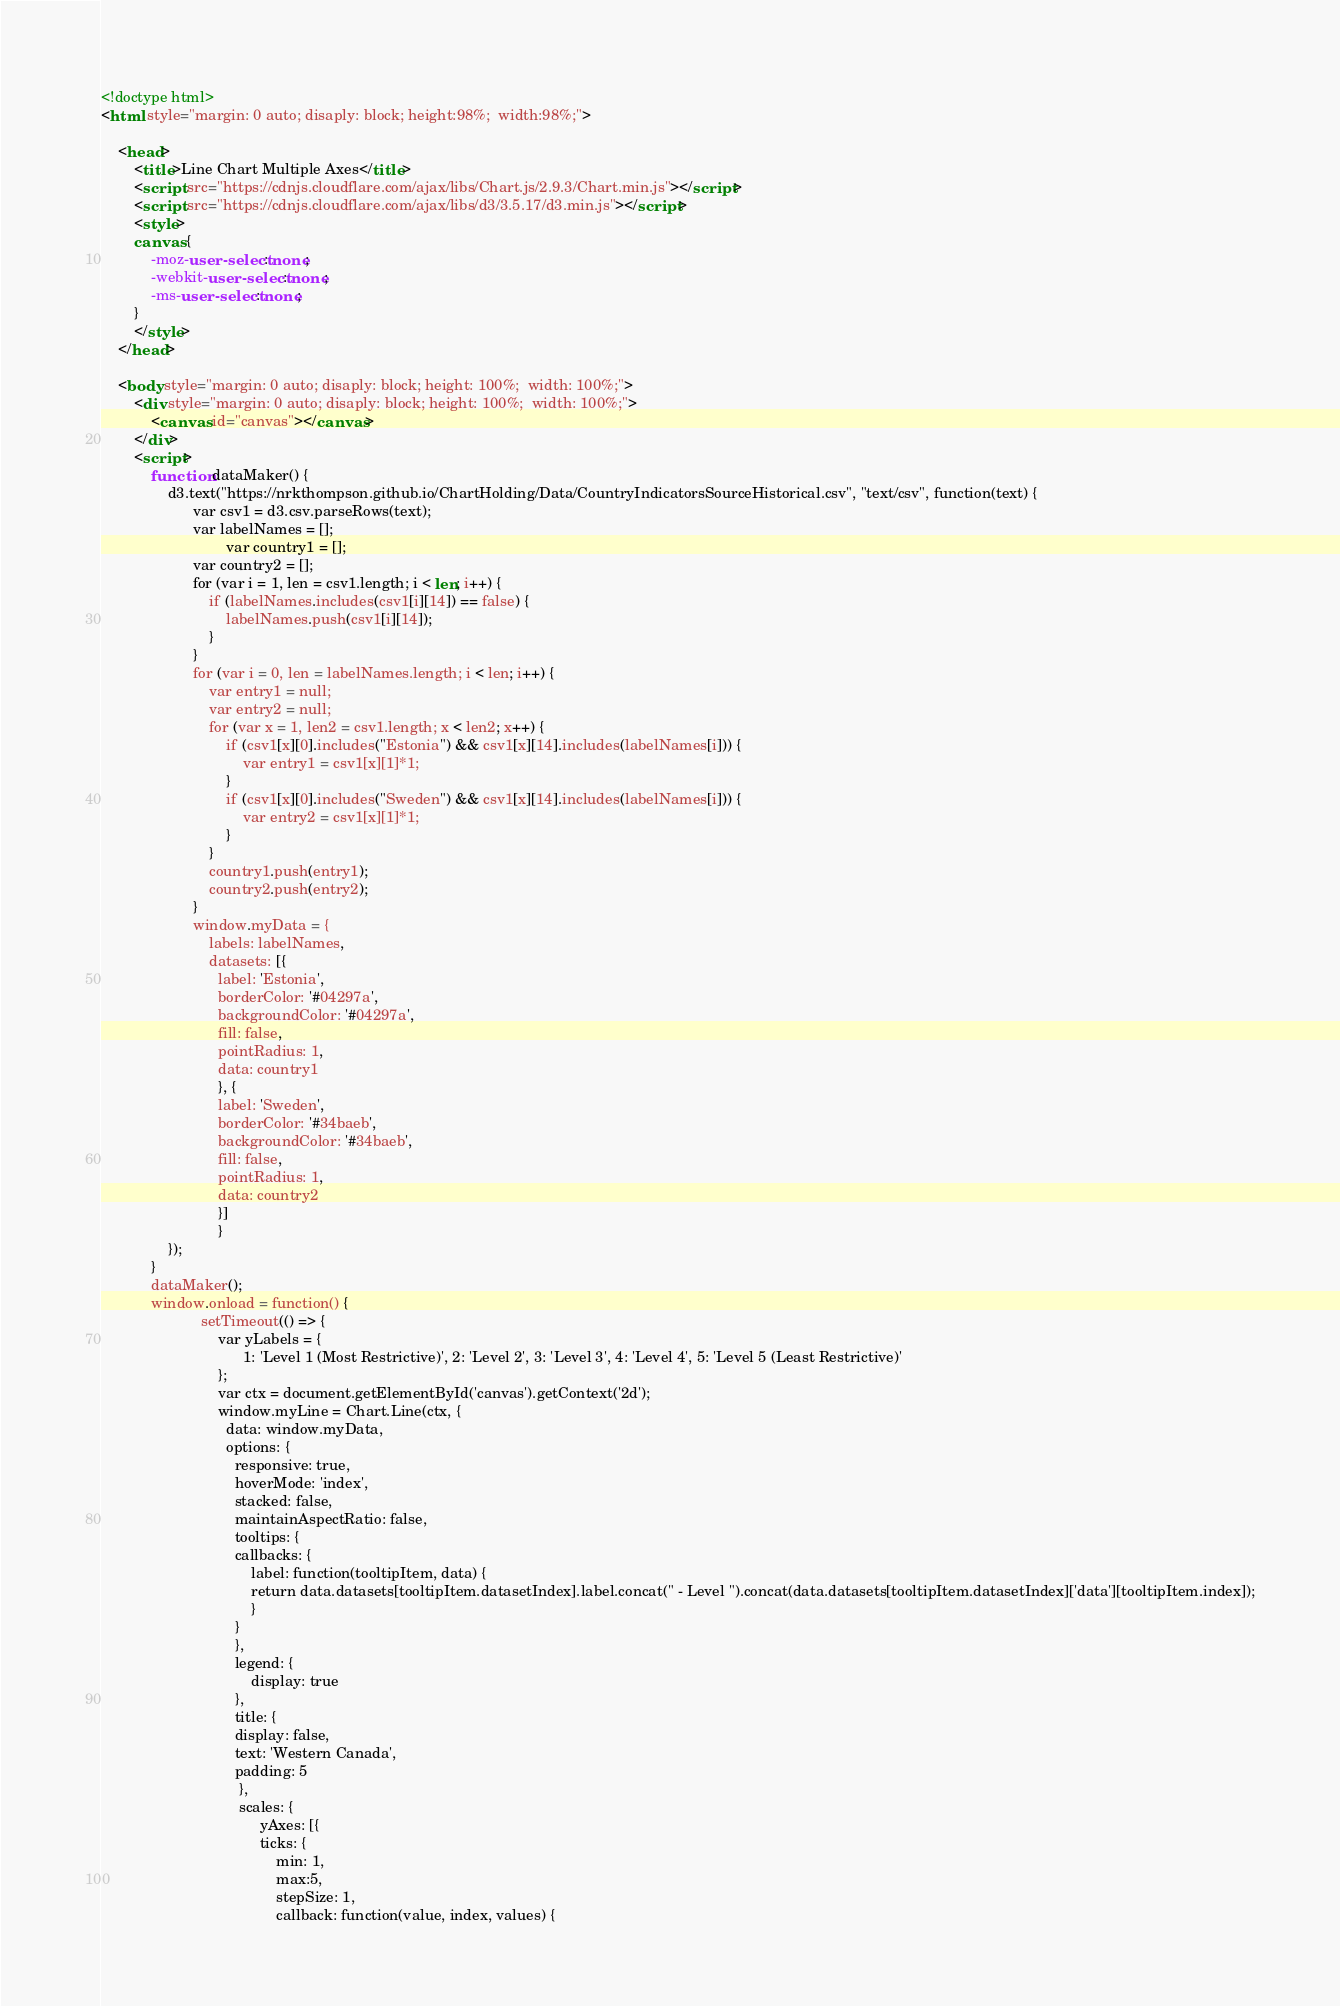Convert code to text. <code><loc_0><loc_0><loc_500><loc_500><_HTML_>
<!doctype html>
<html style="margin: 0 auto; disaply: block; height:98%;  width:98%;">

	<head>
		<title>Line Chart Multiple Axes</title>
		<script src="https://cdnjs.cloudflare.com/ajax/libs/Chart.js/2.9.3/Chart.min.js"></script>
		<script src="https://cdnjs.cloudflare.com/ajax/libs/d3/3.5.17/d3.min.js"></script>
		<style>
		canvas {
			-moz-user-select: none;
			-webkit-user-select: none;
			-ms-user-select: none;
		}
		</style>
	</head>

	<body style="margin: 0 auto; disaply: block; height: 100%;  width: 100%;">
		<div style="margin: 0 auto; disaply: block; height: 100%;  width: 100%;">
			<canvas id="canvas"></canvas>
		</div>
		<script>
			function dataMaker() {
				d3.text("https://nrkthompson.github.io/ChartHolding/Data/CountryIndicatorsSourceHistorical.csv", "text/csv", function(text) {
					  var csv1 = d3.csv.parseRows(text);
					  var labelNames = [];
            				  var country1 = [];
					  var country2 = [];
					  for (var i = 1, len = csv1.length; i < len; i++) {
						  if (labelNames.includes(csv1[i][14]) == false) {
							  labelNames.push(csv1[i][14]);
						  }
					  }
					  for (var i = 0, len = labelNames.length; i < len; i++) {
						  var entry1 = null;
						  var entry2 = null;
						  for (var x = 1, len2 = csv1.length; x < len2; x++) {
							  if (csv1[x][0].includes("Estonia") && csv1[x][14].includes(labelNames[i])) {
								  var entry1 = csv1[x][1]*1;
							  }
							  if (csv1[x][0].includes("Sweden") && csv1[x][14].includes(labelNames[i])) {
								  var entry2 = csv1[x][1]*1;
							  }
						  }
						  country1.push(entry1);
						  country2.push(entry2);
					  }
					  window.myData = {
						  labels: labelNames,
						  datasets: [{
						    label: 'Estonia',
						    borderColor: '#04297a',
						    backgroundColor: '#04297a',
						    fill: false,
						    pointRadius: 1,
						    data: country1
						    }, {
						    label: 'Sweden',
						    borderColor: '#34baeb',
						    backgroundColor: '#34baeb',
						    fill: false,
						    pointRadius: 1,
						    data: country2
						    }]
						    }  
				});
			}
			dataMaker();
			window.onload = function() {
						setTimeout(() => { 
							var yLabels = {
							      1: 'Level 1 (Most Restrictive)', 2: 'Level 2', 3: 'Level 3', 4: 'Level 4', 5: 'Level 5 (Least Restrictive)'
							};
							var ctx = document.getElementById('canvas').getContext('2d');
							window.myLine = Chart.Line(ctx, {
							  data: window.myData,
							  options: {
							    responsive: true,
							    hoverMode: 'index',
							    stacked: false,
							    maintainAspectRatio: false,
							    tooltips: {
								callbacks: {
								    label: function(tooltipItem, data) {
									return data.datasets[tooltipItem.datasetIndex].label.concat(" - Level ").concat(data.datasets[tooltipItem.datasetIndex]['data'][tooltipItem.index]);
								    }
								}
							    },
							    legend: {
								    display: true
							    },
							    title: {
								display: false,
								text: 'Western Canada',
								padding: 5
							     },
							     scales: {
								      yAxes: [{
									  ticks: {
									      min: 1,
									      max:5,
									      stepSize: 1,
									      callback: function(value, index, values) {</code> 